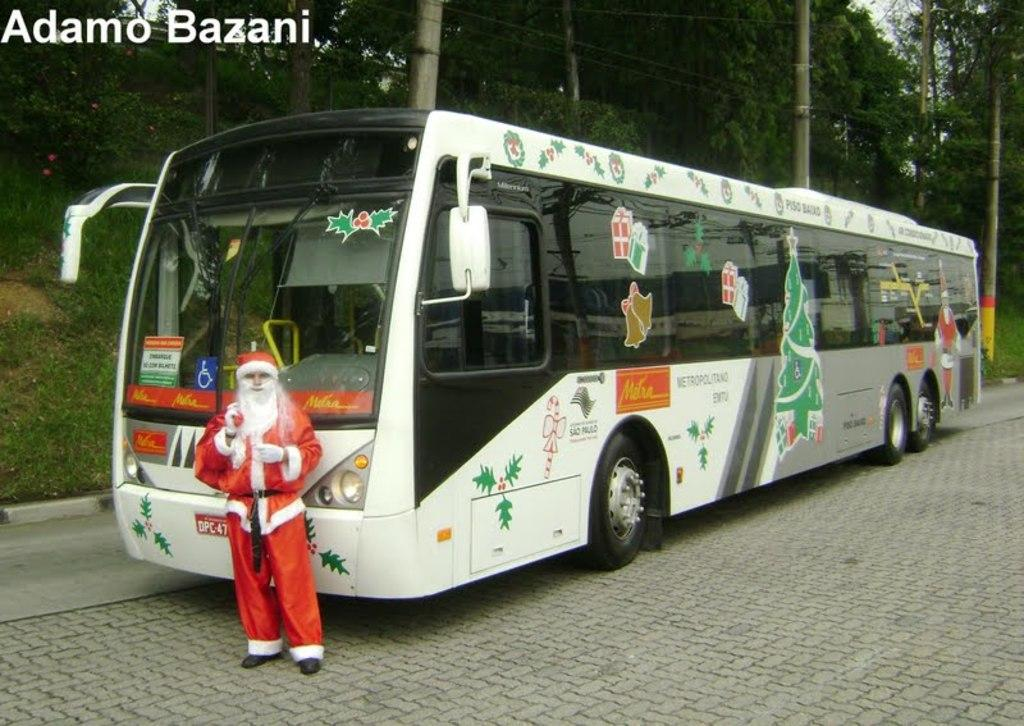What type of vehicle is in the image? There is a white bus in the image. Where is the bus parked? The bus is parked on cobbler stones. Who or what else is present in the image? There is a Santa Claus in the image. What is the Santa Claus doing? The Santa Claus is standing and looking at the camera. What can be seen in the background of the image? There are trees visible in the image. How many fingers does the visitor have in the image? There is no visitor present in the image, only a Santa Claus. What riddle can be solved by looking at the image? There is no riddle present in the image; it simply shows a white bus, Santa Claus, and trees. 